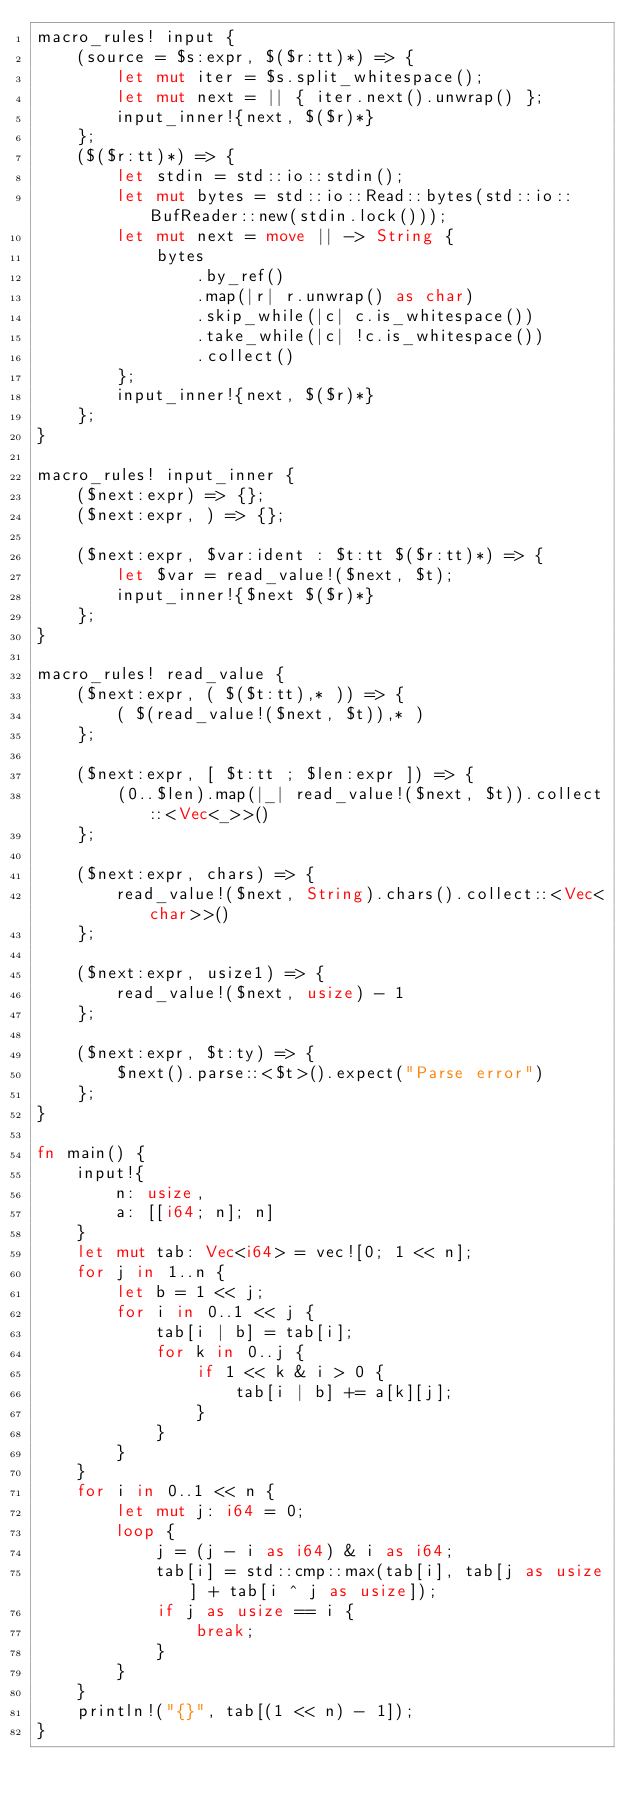<code> <loc_0><loc_0><loc_500><loc_500><_Rust_>macro_rules! input {
    (source = $s:expr, $($r:tt)*) => {
        let mut iter = $s.split_whitespace();
        let mut next = || { iter.next().unwrap() };
        input_inner!{next, $($r)*}
    };
    ($($r:tt)*) => {
        let stdin = std::io::stdin();
        let mut bytes = std::io::Read::bytes(std::io::BufReader::new(stdin.lock()));
        let mut next = move || -> String {
            bytes
                .by_ref()
                .map(|r| r.unwrap() as char)
                .skip_while(|c| c.is_whitespace())
                .take_while(|c| !c.is_whitespace())
                .collect()
        };
        input_inner!{next, $($r)*}
    };
}

macro_rules! input_inner {
    ($next:expr) => {};
    ($next:expr, ) => {};

    ($next:expr, $var:ident : $t:tt $($r:tt)*) => {
        let $var = read_value!($next, $t);
        input_inner!{$next $($r)*}
    };
}

macro_rules! read_value {
    ($next:expr, ( $($t:tt),* )) => {
        ( $(read_value!($next, $t)),* )
    };

    ($next:expr, [ $t:tt ; $len:expr ]) => {
        (0..$len).map(|_| read_value!($next, $t)).collect::<Vec<_>>()
    };

    ($next:expr, chars) => {
        read_value!($next, String).chars().collect::<Vec<char>>()
    };

    ($next:expr, usize1) => {
        read_value!($next, usize) - 1
    };

    ($next:expr, $t:ty) => {
        $next().parse::<$t>().expect("Parse error")
    };
}

fn main() {
    input!{
        n: usize,
        a: [[i64; n]; n]
    }
    let mut tab: Vec<i64> = vec![0; 1 << n];
    for j in 1..n {
        let b = 1 << j;
        for i in 0..1 << j {
            tab[i | b] = tab[i];
            for k in 0..j {
                if 1 << k & i > 0 {
                    tab[i | b] += a[k][j];
                }
            }
        }
    }
    for i in 0..1 << n {
        let mut j: i64 = 0;
        loop {
            j = (j - i as i64) & i as i64;
            tab[i] = std::cmp::max(tab[i], tab[j as usize] + tab[i ^ j as usize]);
            if j as usize == i {
                break;
            }
        }
    }
    println!("{}", tab[(1 << n) - 1]);
}
</code> 